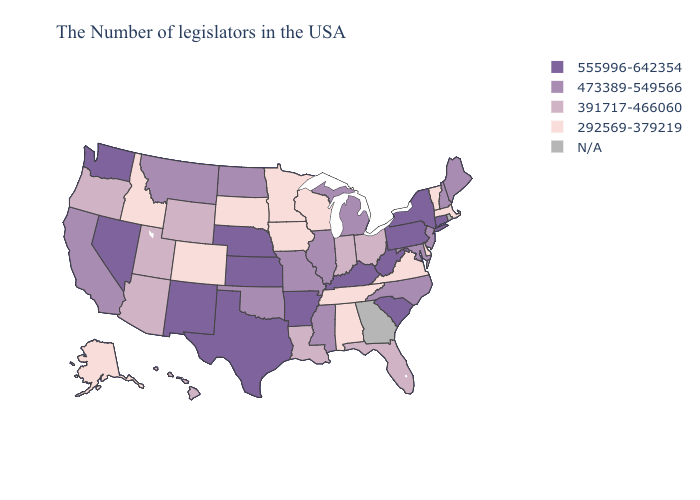Name the states that have a value in the range 391717-466060?
Write a very short answer. Ohio, Florida, Indiana, Louisiana, Wyoming, Utah, Arizona, Oregon, Hawaii. Which states hav the highest value in the South?
Short answer required. South Carolina, West Virginia, Kentucky, Arkansas, Texas. Name the states that have a value in the range 473389-549566?
Concise answer only. Maine, New Hampshire, New Jersey, Maryland, North Carolina, Michigan, Illinois, Mississippi, Missouri, Oklahoma, North Dakota, Montana, California. What is the value of Nevada?
Give a very brief answer. 555996-642354. Name the states that have a value in the range 555996-642354?
Be succinct. Connecticut, New York, Pennsylvania, South Carolina, West Virginia, Kentucky, Arkansas, Kansas, Nebraska, Texas, New Mexico, Nevada, Washington. Is the legend a continuous bar?
Keep it brief. No. What is the value of New Mexico?
Quick response, please. 555996-642354. Which states have the lowest value in the West?
Give a very brief answer. Colorado, Idaho, Alaska. Name the states that have a value in the range 555996-642354?
Short answer required. Connecticut, New York, Pennsylvania, South Carolina, West Virginia, Kentucky, Arkansas, Kansas, Nebraska, Texas, New Mexico, Nevada, Washington. Name the states that have a value in the range N/A?
Short answer required. Rhode Island, Georgia. Does Vermont have the lowest value in the Northeast?
Quick response, please. Yes. Is the legend a continuous bar?
Give a very brief answer. No. What is the value of Delaware?
Be succinct. 292569-379219. What is the highest value in the West ?
Keep it brief. 555996-642354. What is the value of Mississippi?
Be succinct. 473389-549566. 